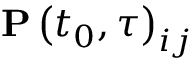Convert formula to latex. <formula><loc_0><loc_0><loc_500><loc_500>P \left ( t _ { 0 } , \tau \right ) _ { i j }</formula> 